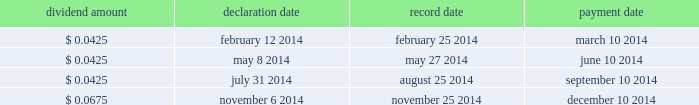Overview we finance our operations and capital expenditures through a combination of internally generated cash from operations and from borrowings under our senior secured asset-based revolving credit facility .
We believe that our current sources of funds will be sufficient to fund our cash operating requirements for the next year .
In addition , we believe that , in spite of the uncertainty of future macroeconomic conditions , we have adequate sources of liquidity and funding available to meet our longer-term needs .
However , there are a number of factors that may negatively impact our available sources of funds .
The amount of cash generated from operations will be dependent upon factors such as the successful execution of our business plan and general economic conditions .
Long-term debt activities during the year ended december 31 , 2014 , we had significant debt refinancings .
In connection with these refinancings , we recorded a loss on extinguishment of long-term debt of $ 90.7 million in our consolidated statement of operations for the year ended december 31 , 2014 .
See note 7 to the accompanying audited consolidated financial statements included elsewhere in this report for additional details .
Share repurchase program on november 6 , 2014 , we announced that our board of directors approved a $ 500 million share repurchase program effective immediately under which we may repurchase shares of our common stock in the open market or through privately negotiated transactions , depending on share price , market conditions and other factors .
The share repurchase program does not obligate us to repurchase any dollar amount or number of shares , and repurchases may be commenced or suspended from time to time without prior notice .
As of the date of this filing , no shares have been repurchased under the share repurchase program .
Dividends a summary of 2014 dividend activity for our common stock is shown below: .
On february 10 , 2015 , we announced that our board of directors declared a quarterly cash dividend on our common stock of $ 0.0675 per share .
The dividend will be paid on march 10 , 2015 to all stockholders of record as of the close of business on february 25 , 2015 .
The payment of any future dividends will be at the discretion of our board of directors and will depend upon our results of operations , financial condition , business prospects , capital requirements , contractual restrictions , any potential indebtedness we may incur , restrictions imposed by applicable law , tax considerations and other factors that our board of directors deems relevant .
In addition , our ability to pay dividends on our common stock will be limited by restrictions on our ability to pay dividends or make distributions to our stockholders and on the ability of our subsidiaries to pay dividends or make distributions to us , in each case , under the terms of our current and any future agreements governing our indebtedness .
Table of contents .
What was the dividend increase between july 31 2014 and november 6 2014? 
Computations: (0.0675 - 0.0425)
Answer: 0.025. 